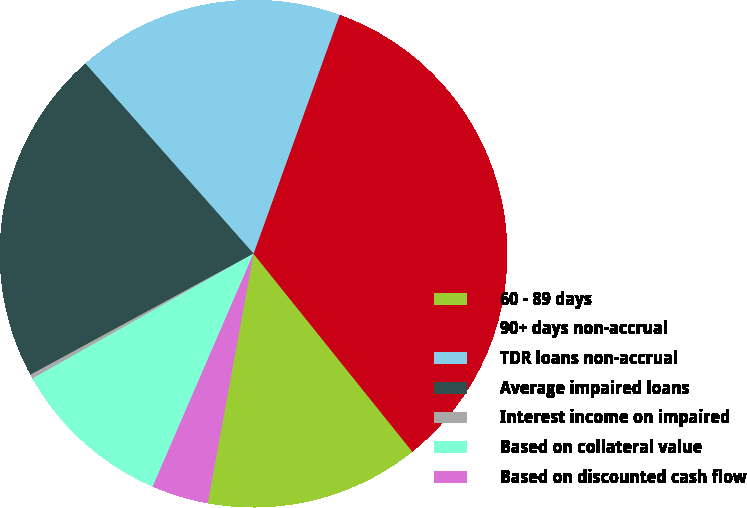Convert chart to OTSL. <chart><loc_0><loc_0><loc_500><loc_500><pie_chart><fcel>60 - 89 days<fcel>90+ days non-accrual<fcel>TDR loans non-accrual<fcel>Average impaired loans<fcel>Interest income on impaired<fcel>Based on collateral value<fcel>Based on discounted cash flow<nl><fcel>13.65%<fcel>33.73%<fcel>17.03%<fcel>21.39%<fcel>0.27%<fcel>10.31%<fcel>3.61%<nl></chart> 